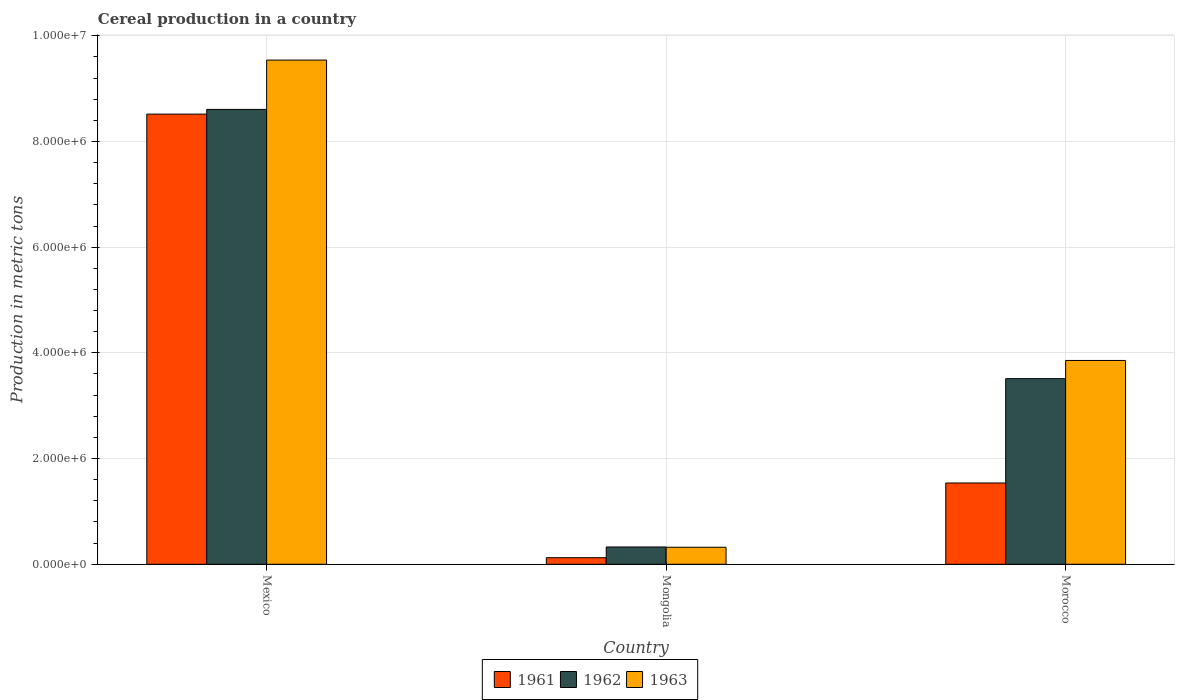How many different coloured bars are there?
Your answer should be very brief. 3. Are the number of bars per tick equal to the number of legend labels?
Your answer should be compact. Yes. Are the number of bars on each tick of the X-axis equal?
Offer a terse response. Yes. How many bars are there on the 3rd tick from the left?
Provide a short and direct response. 3. In how many cases, is the number of bars for a given country not equal to the number of legend labels?
Your response must be concise. 0. What is the total cereal production in 1962 in Mexico?
Your answer should be compact. 8.61e+06. Across all countries, what is the maximum total cereal production in 1962?
Provide a short and direct response. 8.61e+06. Across all countries, what is the minimum total cereal production in 1961?
Offer a very short reply. 1.24e+05. In which country was the total cereal production in 1962 minimum?
Make the answer very short. Mongolia. What is the total total cereal production in 1961 in the graph?
Keep it short and to the point. 1.02e+07. What is the difference between the total cereal production in 1963 in Mexico and that in Mongolia?
Offer a very short reply. 9.22e+06. What is the difference between the total cereal production in 1963 in Morocco and the total cereal production in 1961 in Mongolia?
Ensure brevity in your answer.  3.73e+06. What is the average total cereal production in 1961 per country?
Your answer should be very brief. 3.39e+06. What is the difference between the total cereal production of/in 1961 and total cereal production of/in 1963 in Morocco?
Your answer should be very brief. -2.32e+06. What is the ratio of the total cereal production in 1961 in Mongolia to that in Morocco?
Your answer should be compact. 0.08. What is the difference between the highest and the second highest total cereal production in 1963?
Provide a succinct answer. -9.22e+06. What is the difference between the highest and the lowest total cereal production in 1961?
Your answer should be compact. 8.39e+06. In how many countries, is the total cereal production in 1962 greater than the average total cereal production in 1962 taken over all countries?
Your answer should be very brief. 1. What does the 2nd bar from the right in Mongolia represents?
Your answer should be compact. 1962. Is it the case that in every country, the sum of the total cereal production in 1961 and total cereal production in 1963 is greater than the total cereal production in 1962?
Offer a very short reply. Yes. How many bars are there?
Your response must be concise. 9. Are all the bars in the graph horizontal?
Your answer should be compact. No. How many countries are there in the graph?
Keep it short and to the point. 3. What is the difference between two consecutive major ticks on the Y-axis?
Your answer should be compact. 2.00e+06. Does the graph contain grids?
Offer a very short reply. Yes. How many legend labels are there?
Your answer should be compact. 3. How are the legend labels stacked?
Ensure brevity in your answer.  Horizontal. What is the title of the graph?
Make the answer very short. Cereal production in a country. Does "2003" appear as one of the legend labels in the graph?
Provide a short and direct response. No. What is the label or title of the X-axis?
Give a very brief answer. Country. What is the label or title of the Y-axis?
Provide a short and direct response. Production in metric tons. What is the Production in metric tons in 1961 in Mexico?
Provide a succinct answer. 8.52e+06. What is the Production in metric tons of 1962 in Mexico?
Give a very brief answer. 8.61e+06. What is the Production in metric tons in 1963 in Mexico?
Provide a short and direct response. 9.54e+06. What is the Production in metric tons of 1961 in Mongolia?
Give a very brief answer. 1.24e+05. What is the Production in metric tons of 1962 in Mongolia?
Give a very brief answer. 3.27e+05. What is the Production in metric tons in 1963 in Mongolia?
Ensure brevity in your answer.  3.22e+05. What is the Production in metric tons in 1961 in Morocco?
Give a very brief answer. 1.54e+06. What is the Production in metric tons of 1962 in Morocco?
Your answer should be compact. 3.51e+06. What is the Production in metric tons of 1963 in Morocco?
Provide a succinct answer. 3.86e+06. Across all countries, what is the maximum Production in metric tons of 1961?
Your answer should be very brief. 8.52e+06. Across all countries, what is the maximum Production in metric tons of 1962?
Make the answer very short. 8.61e+06. Across all countries, what is the maximum Production in metric tons in 1963?
Ensure brevity in your answer.  9.54e+06. Across all countries, what is the minimum Production in metric tons in 1961?
Provide a short and direct response. 1.24e+05. Across all countries, what is the minimum Production in metric tons in 1962?
Your answer should be very brief. 3.27e+05. Across all countries, what is the minimum Production in metric tons of 1963?
Keep it short and to the point. 3.22e+05. What is the total Production in metric tons of 1961 in the graph?
Offer a very short reply. 1.02e+07. What is the total Production in metric tons in 1962 in the graph?
Make the answer very short. 1.24e+07. What is the total Production in metric tons in 1963 in the graph?
Offer a terse response. 1.37e+07. What is the difference between the Production in metric tons of 1961 in Mexico and that in Mongolia?
Give a very brief answer. 8.39e+06. What is the difference between the Production in metric tons of 1962 in Mexico and that in Mongolia?
Offer a very short reply. 8.28e+06. What is the difference between the Production in metric tons in 1963 in Mexico and that in Mongolia?
Provide a succinct answer. 9.22e+06. What is the difference between the Production in metric tons of 1961 in Mexico and that in Morocco?
Provide a succinct answer. 6.98e+06. What is the difference between the Production in metric tons of 1962 in Mexico and that in Morocco?
Your response must be concise. 5.09e+06. What is the difference between the Production in metric tons in 1963 in Mexico and that in Morocco?
Provide a short and direct response. 5.68e+06. What is the difference between the Production in metric tons of 1961 in Mongolia and that in Morocco?
Provide a short and direct response. -1.41e+06. What is the difference between the Production in metric tons of 1962 in Mongolia and that in Morocco?
Your response must be concise. -3.18e+06. What is the difference between the Production in metric tons in 1963 in Mongolia and that in Morocco?
Your answer should be very brief. -3.53e+06. What is the difference between the Production in metric tons of 1961 in Mexico and the Production in metric tons of 1962 in Mongolia?
Your response must be concise. 8.19e+06. What is the difference between the Production in metric tons in 1961 in Mexico and the Production in metric tons in 1963 in Mongolia?
Offer a very short reply. 8.19e+06. What is the difference between the Production in metric tons in 1962 in Mexico and the Production in metric tons in 1963 in Mongolia?
Give a very brief answer. 8.28e+06. What is the difference between the Production in metric tons in 1961 in Mexico and the Production in metric tons in 1962 in Morocco?
Make the answer very short. 5.00e+06. What is the difference between the Production in metric tons of 1961 in Mexico and the Production in metric tons of 1963 in Morocco?
Offer a very short reply. 4.66e+06. What is the difference between the Production in metric tons of 1962 in Mexico and the Production in metric tons of 1963 in Morocco?
Offer a very short reply. 4.75e+06. What is the difference between the Production in metric tons of 1961 in Mongolia and the Production in metric tons of 1962 in Morocco?
Your response must be concise. -3.39e+06. What is the difference between the Production in metric tons of 1961 in Mongolia and the Production in metric tons of 1963 in Morocco?
Provide a short and direct response. -3.73e+06. What is the difference between the Production in metric tons of 1962 in Mongolia and the Production in metric tons of 1963 in Morocco?
Offer a terse response. -3.53e+06. What is the average Production in metric tons in 1961 per country?
Your response must be concise. 3.39e+06. What is the average Production in metric tons of 1962 per country?
Make the answer very short. 4.15e+06. What is the average Production in metric tons of 1963 per country?
Give a very brief answer. 4.57e+06. What is the difference between the Production in metric tons of 1961 and Production in metric tons of 1962 in Mexico?
Keep it short and to the point. -8.91e+04. What is the difference between the Production in metric tons in 1961 and Production in metric tons in 1963 in Mexico?
Your response must be concise. -1.02e+06. What is the difference between the Production in metric tons of 1962 and Production in metric tons of 1963 in Mexico?
Keep it short and to the point. -9.33e+05. What is the difference between the Production in metric tons of 1961 and Production in metric tons of 1962 in Mongolia?
Your answer should be very brief. -2.03e+05. What is the difference between the Production in metric tons of 1961 and Production in metric tons of 1963 in Mongolia?
Your answer should be very brief. -1.98e+05. What is the difference between the Production in metric tons of 1962 and Production in metric tons of 1963 in Mongolia?
Ensure brevity in your answer.  5200. What is the difference between the Production in metric tons in 1961 and Production in metric tons in 1962 in Morocco?
Your answer should be very brief. -1.97e+06. What is the difference between the Production in metric tons in 1961 and Production in metric tons in 1963 in Morocco?
Provide a short and direct response. -2.32e+06. What is the difference between the Production in metric tons of 1962 and Production in metric tons of 1963 in Morocco?
Provide a succinct answer. -3.44e+05. What is the ratio of the Production in metric tons of 1961 in Mexico to that in Mongolia?
Your response must be concise. 68.46. What is the ratio of the Production in metric tons of 1962 in Mexico to that in Mongolia?
Your answer should be compact. 26.29. What is the ratio of the Production in metric tons of 1963 in Mexico to that in Mongolia?
Your answer should be very brief. 29.61. What is the ratio of the Production in metric tons in 1961 in Mexico to that in Morocco?
Your response must be concise. 5.54. What is the ratio of the Production in metric tons of 1962 in Mexico to that in Morocco?
Keep it short and to the point. 2.45. What is the ratio of the Production in metric tons in 1963 in Mexico to that in Morocco?
Make the answer very short. 2.47. What is the ratio of the Production in metric tons in 1961 in Mongolia to that in Morocco?
Make the answer very short. 0.08. What is the ratio of the Production in metric tons of 1962 in Mongolia to that in Morocco?
Give a very brief answer. 0.09. What is the ratio of the Production in metric tons of 1963 in Mongolia to that in Morocco?
Your response must be concise. 0.08. What is the difference between the highest and the second highest Production in metric tons of 1961?
Your answer should be compact. 6.98e+06. What is the difference between the highest and the second highest Production in metric tons in 1962?
Make the answer very short. 5.09e+06. What is the difference between the highest and the second highest Production in metric tons in 1963?
Offer a terse response. 5.68e+06. What is the difference between the highest and the lowest Production in metric tons of 1961?
Your response must be concise. 8.39e+06. What is the difference between the highest and the lowest Production in metric tons of 1962?
Offer a terse response. 8.28e+06. What is the difference between the highest and the lowest Production in metric tons in 1963?
Keep it short and to the point. 9.22e+06. 